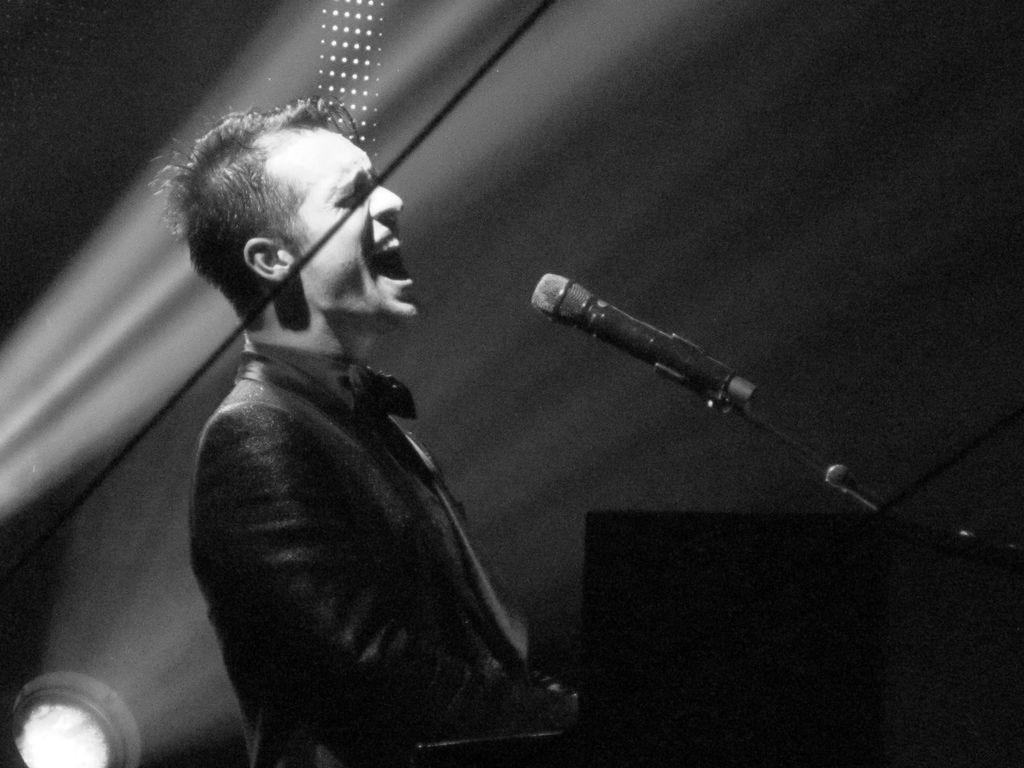What is the man in the image doing? The man is singing in the image. What is the man using to amplify his voice? There is a microphone in front of the man. How would you describe the lighting in the image? The background of the image is dark. Can you identify any additional lighting in the image? Yes, there is a focusing light in the bottom left of the image. What type of skirt is the fish wearing in the image? There is no fish or skirt present in the image. 